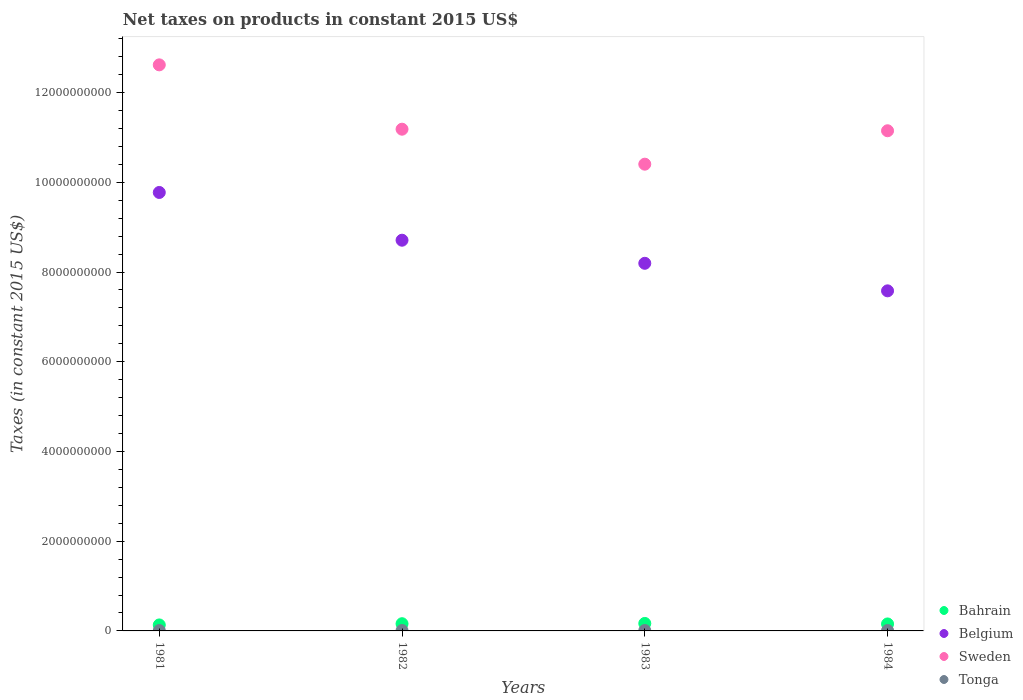How many different coloured dotlines are there?
Provide a succinct answer. 4. Is the number of dotlines equal to the number of legend labels?
Make the answer very short. Yes. What is the net taxes on products in Bahrain in 1984?
Ensure brevity in your answer.  1.56e+08. Across all years, what is the maximum net taxes on products in Belgium?
Your answer should be very brief. 9.77e+09. Across all years, what is the minimum net taxes on products in Tonga?
Keep it short and to the point. 8.35e+06. In which year was the net taxes on products in Sweden minimum?
Make the answer very short. 1983. What is the total net taxes on products in Belgium in the graph?
Give a very brief answer. 3.43e+1. What is the difference between the net taxes on products in Bahrain in 1982 and that in 1983?
Offer a very short reply. -6.12e+06. What is the difference between the net taxes on products in Tonga in 1983 and the net taxes on products in Sweden in 1981?
Keep it short and to the point. -1.26e+1. What is the average net taxes on products in Tonga per year?
Offer a very short reply. 8.68e+06. In the year 1983, what is the difference between the net taxes on products in Belgium and net taxes on products in Sweden?
Keep it short and to the point. -2.21e+09. In how many years, is the net taxes on products in Belgium greater than 5200000000 US$?
Make the answer very short. 4. What is the ratio of the net taxes on products in Belgium in 1982 to that in 1984?
Offer a terse response. 1.15. What is the difference between the highest and the second highest net taxes on products in Belgium?
Provide a short and direct response. 1.06e+09. What is the difference between the highest and the lowest net taxes on products in Tonga?
Keep it short and to the point. 5.08e+05. In how many years, is the net taxes on products in Tonga greater than the average net taxes on products in Tonga taken over all years?
Provide a short and direct response. 3. Is the sum of the net taxes on products in Belgium in 1982 and 1984 greater than the maximum net taxes on products in Sweden across all years?
Your answer should be compact. Yes. Is it the case that in every year, the sum of the net taxes on products in Bahrain and net taxes on products in Belgium  is greater than the sum of net taxes on products in Sweden and net taxes on products in Tonga?
Provide a succinct answer. No. Is it the case that in every year, the sum of the net taxes on products in Belgium and net taxes on products in Sweden  is greater than the net taxes on products in Bahrain?
Make the answer very short. Yes. Does the net taxes on products in Bahrain monotonically increase over the years?
Offer a very short reply. No. Is the net taxes on products in Tonga strictly greater than the net taxes on products in Sweden over the years?
Ensure brevity in your answer.  No. How many dotlines are there?
Keep it short and to the point. 4. What is the difference between two consecutive major ticks on the Y-axis?
Your response must be concise. 2.00e+09. Are the values on the major ticks of Y-axis written in scientific E-notation?
Ensure brevity in your answer.  No. How are the legend labels stacked?
Offer a very short reply. Vertical. What is the title of the graph?
Provide a short and direct response. Net taxes on products in constant 2015 US$. What is the label or title of the X-axis?
Provide a short and direct response. Years. What is the label or title of the Y-axis?
Give a very brief answer. Taxes (in constant 2015 US$). What is the Taxes (in constant 2015 US$) of Bahrain in 1981?
Offer a terse response. 1.34e+08. What is the Taxes (in constant 2015 US$) of Belgium in 1981?
Keep it short and to the point. 9.77e+09. What is the Taxes (in constant 2015 US$) of Sweden in 1981?
Provide a succinct answer. 1.26e+1. What is the Taxes (in constant 2015 US$) of Tonga in 1981?
Your answer should be compact. 8.35e+06. What is the Taxes (in constant 2015 US$) in Bahrain in 1982?
Offer a very short reply. 1.61e+08. What is the Taxes (in constant 2015 US$) in Belgium in 1982?
Ensure brevity in your answer.  8.71e+09. What is the Taxes (in constant 2015 US$) in Sweden in 1982?
Provide a succinct answer. 1.12e+1. What is the Taxes (in constant 2015 US$) of Tonga in 1982?
Provide a short and direct response. 8.80e+06. What is the Taxes (in constant 2015 US$) of Bahrain in 1983?
Your answer should be very brief. 1.67e+08. What is the Taxes (in constant 2015 US$) of Belgium in 1983?
Provide a short and direct response. 8.20e+09. What is the Taxes (in constant 2015 US$) of Sweden in 1983?
Make the answer very short. 1.04e+1. What is the Taxes (in constant 2015 US$) of Tonga in 1983?
Your answer should be compact. 8.72e+06. What is the Taxes (in constant 2015 US$) in Bahrain in 1984?
Give a very brief answer. 1.56e+08. What is the Taxes (in constant 2015 US$) in Belgium in 1984?
Make the answer very short. 7.58e+09. What is the Taxes (in constant 2015 US$) in Sweden in 1984?
Offer a terse response. 1.11e+1. What is the Taxes (in constant 2015 US$) in Tonga in 1984?
Make the answer very short. 8.86e+06. Across all years, what is the maximum Taxes (in constant 2015 US$) of Bahrain?
Your response must be concise. 1.67e+08. Across all years, what is the maximum Taxes (in constant 2015 US$) in Belgium?
Provide a succinct answer. 9.77e+09. Across all years, what is the maximum Taxes (in constant 2015 US$) in Sweden?
Offer a very short reply. 1.26e+1. Across all years, what is the maximum Taxes (in constant 2015 US$) in Tonga?
Provide a short and direct response. 8.86e+06. Across all years, what is the minimum Taxes (in constant 2015 US$) in Bahrain?
Make the answer very short. 1.34e+08. Across all years, what is the minimum Taxes (in constant 2015 US$) in Belgium?
Offer a terse response. 7.58e+09. Across all years, what is the minimum Taxes (in constant 2015 US$) in Sweden?
Provide a short and direct response. 1.04e+1. Across all years, what is the minimum Taxes (in constant 2015 US$) in Tonga?
Your answer should be compact. 8.35e+06. What is the total Taxes (in constant 2015 US$) of Bahrain in the graph?
Provide a succinct answer. 6.16e+08. What is the total Taxes (in constant 2015 US$) of Belgium in the graph?
Your answer should be very brief. 3.43e+1. What is the total Taxes (in constant 2015 US$) in Sweden in the graph?
Your answer should be very brief. 4.54e+1. What is the total Taxes (in constant 2015 US$) of Tonga in the graph?
Provide a succinct answer. 3.47e+07. What is the difference between the Taxes (in constant 2015 US$) in Bahrain in 1981 and that in 1982?
Offer a terse response. -2.71e+07. What is the difference between the Taxes (in constant 2015 US$) of Belgium in 1981 and that in 1982?
Offer a terse response. 1.06e+09. What is the difference between the Taxes (in constant 2015 US$) of Sweden in 1981 and that in 1982?
Provide a succinct answer. 1.43e+09. What is the difference between the Taxes (in constant 2015 US$) of Tonga in 1981 and that in 1982?
Your answer should be compact. -4.48e+05. What is the difference between the Taxes (in constant 2015 US$) of Bahrain in 1981 and that in 1983?
Your answer should be compact. -3.32e+07. What is the difference between the Taxes (in constant 2015 US$) in Belgium in 1981 and that in 1983?
Keep it short and to the point. 1.58e+09. What is the difference between the Taxes (in constant 2015 US$) in Sweden in 1981 and that in 1983?
Ensure brevity in your answer.  2.21e+09. What is the difference between the Taxes (in constant 2015 US$) of Tonga in 1981 and that in 1983?
Give a very brief answer. -3.70e+05. What is the difference between the Taxes (in constant 2015 US$) of Bahrain in 1981 and that in 1984?
Provide a short and direct response. -2.21e+07. What is the difference between the Taxes (in constant 2015 US$) of Belgium in 1981 and that in 1984?
Your response must be concise. 2.19e+09. What is the difference between the Taxes (in constant 2015 US$) in Sweden in 1981 and that in 1984?
Your answer should be compact. 1.47e+09. What is the difference between the Taxes (in constant 2015 US$) of Tonga in 1981 and that in 1984?
Make the answer very short. -5.08e+05. What is the difference between the Taxes (in constant 2015 US$) in Bahrain in 1982 and that in 1983?
Your answer should be very brief. -6.12e+06. What is the difference between the Taxes (in constant 2015 US$) of Belgium in 1982 and that in 1983?
Provide a succinct answer. 5.15e+08. What is the difference between the Taxes (in constant 2015 US$) of Sweden in 1982 and that in 1983?
Offer a very short reply. 7.80e+08. What is the difference between the Taxes (in constant 2015 US$) of Tonga in 1982 and that in 1983?
Give a very brief answer. 7.82e+04. What is the difference between the Taxes (in constant 2015 US$) of Bahrain in 1982 and that in 1984?
Keep it short and to the point. 5.05e+06. What is the difference between the Taxes (in constant 2015 US$) of Belgium in 1982 and that in 1984?
Your answer should be compact. 1.13e+09. What is the difference between the Taxes (in constant 2015 US$) in Sweden in 1982 and that in 1984?
Keep it short and to the point. 3.50e+07. What is the difference between the Taxes (in constant 2015 US$) in Tonga in 1982 and that in 1984?
Your answer should be very brief. -5.93e+04. What is the difference between the Taxes (in constant 2015 US$) in Bahrain in 1983 and that in 1984?
Ensure brevity in your answer.  1.12e+07. What is the difference between the Taxes (in constant 2015 US$) in Belgium in 1983 and that in 1984?
Keep it short and to the point. 6.14e+08. What is the difference between the Taxes (in constant 2015 US$) of Sweden in 1983 and that in 1984?
Offer a terse response. -7.45e+08. What is the difference between the Taxes (in constant 2015 US$) in Tonga in 1983 and that in 1984?
Offer a very short reply. -1.38e+05. What is the difference between the Taxes (in constant 2015 US$) of Bahrain in 1981 and the Taxes (in constant 2015 US$) of Belgium in 1982?
Ensure brevity in your answer.  -8.58e+09. What is the difference between the Taxes (in constant 2015 US$) in Bahrain in 1981 and the Taxes (in constant 2015 US$) in Sweden in 1982?
Your response must be concise. -1.11e+1. What is the difference between the Taxes (in constant 2015 US$) of Bahrain in 1981 and the Taxes (in constant 2015 US$) of Tonga in 1982?
Offer a very short reply. 1.25e+08. What is the difference between the Taxes (in constant 2015 US$) in Belgium in 1981 and the Taxes (in constant 2015 US$) in Sweden in 1982?
Keep it short and to the point. -1.41e+09. What is the difference between the Taxes (in constant 2015 US$) in Belgium in 1981 and the Taxes (in constant 2015 US$) in Tonga in 1982?
Provide a succinct answer. 9.77e+09. What is the difference between the Taxes (in constant 2015 US$) in Sweden in 1981 and the Taxes (in constant 2015 US$) in Tonga in 1982?
Provide a short and direct response. 1.26e+1. What is the difference between the Taxes (in constant 2015 US$) of Bahrain in 1981 and the Taxes (in constant 2015 US$) of Belgium in 1983?
Provide a short and direct response. -8.06e+09. What is the difference between the Taxes (in constant 2015 US$) in Bahrain in 1981 and the Taxes (in constant 2015 US$) in Sweden in 1983?
Your answer should be very brief. -1.03e+1. What is the difference between the Taxes (in constant 2015 US$) in Bahrain in 1981 and the Taxes (in constant 2015 US$) in Tonga in 1983?
Provide a short and direct response. 1.25e+08. What is the difference between the Taxes (in constant 2015 US$) in Belgium in 1981 and the Taxes (in constant 2015 US$) in Sweden in 1983?
Provide a short and direct response. -6.30e+08. What is the difference between the Taxes (in constant 2015 US$) of Belgium in 1981 and the Taxes (in constant 2015 US$) of Tonga in 1983?
Give a very brief answer. 9.77e+09. What is the difference between the Taxes (in constant 2015 US$) in Sweden in 1981 and the Taxes (in constant 2015 US$) in Tonga in 1983?
Your answer should be compact. 1.26e+1. What is the difference between the Taxes (in constant 2015 US$) in Bahrain in 1981 and the Taxes (in constant 2015 US$) in Belgium in 1984?
Ensure brevity in your answer.  -7.45e+09. What is the difference between the Taxes (in constant 2015 US$) in Bahrain in 1981 and the Taxes (in constant 2015 US$) in Sweden in 1984?
Give a very brief answer. -1.10e+1. What is the difference between the Taxes (in constant 2015 US$) of Bahrain in 1981 and the Taxes (in constant 2015 US$) of Tonga in 1984?
Provide a succinct answer. 1.25e+08. What is the difference between the Taxes (in constant 2015 US$) in Belgium in 1981 and the Taxes (in constant 2015 US$) in Sweden in 1984?
Ensure brevity in your answer.  -1.38e+09. What is the difference between the Taxes (in constant 2015 US$) in Belgium in 1981 and the Taxes (in constant 2015 US$) in Tonga in 1984?
Your answer should be compact. 9.77e+09. What is the difference between the Taxes (in constant 2015 US$) of Sweden in 1981 and the Taxes (in constant 2015 US$) of Tonga in 1984?
Ensure brevity in your answer.  1.26e+1. What is the difference between the Taxes (in constant 2015 US$) in Bahrain in 1982 and the Taxes (in constant 2015 US$) in Belgium in 1983?
Offer a very short reply. -8.03e+09. What is the difference between the Taxes (in constant 2015 US$) of Bahrain in 1982 and the Taxes (in constant 2015 US$) of Sweden in 1983?
Keep it short and to the point. -1.02e+1. What is the difference between the Taxes (in constant 2015 US$) of Bahrain in 1982 and the Taxes (in constant 2015 US$) of Tonga in 1983?
Offer a terse response. 1.52e+08. What is the difference between the Taxes (in constant 2015 US$) in Belgium in 1982 and the Taxes (in constant 2015 US$) in Sweden in 1983?
Provide a short and direct response. -1.69e+09. What is the difference between the Taxes (in constant 2015 US$) in Belgium in 1982 and the Taxes (in constant 2015 US$) in Tonga in 1983?
Your answer should be very brief. 8.70e+09. What is the difference between the Taxes (in constant 2015 US$) in Sweden in 1982 and the Taxes (in constant 2015 US$) in Tonga in 1983?
Offer a very short reply. 1.12e+1. What is the difference between the Taxes (in constant 2015 US$) in Bahrain in 1982 and the Taxes (in constant 2015 US$) in Belgium in 1984?
Give a very brief answer. -7.42e+09. What is the difference between the Taxes (in constant 2015 US$) of Bahrain in 1982 and the Taxes (in constant 2015 US$) of Sweden in 1984?
Give a very brief answer. -1.10e+1. What is the difference between the Taxes (in constant 2015 US$) in Bahrain in 1982 and the Taxes (in constant 2015 US$) in Tonga in 1984?
Ensure brevity in your answer.  1.52e+08. What is the difference between the Taxes (in constant 2015 US$) in Belgium in 1982 and the Taxes (in constant 2015 US$) in Sweden in 1984?
Keep it short and to the point. -2.44e+09. What is the difference between the Taxes (in constant 2015 US$) of Belgium in 1982 and the Taxes (in constant 2015 US$) of Tonga in 1984?
Your answer should be very brief. 8.70e+09. What is the difference between the Taxes (in constant 2015 US$) of Sweden in 1982 and the Taxes (in constant 2015 US$) of Tonga in 1984?
Offer a very short reply. 1.12e+1. What is the difference between the Taxes (in constant 2015 US$) of Bahrain in 1983 and the Taxes (in constant 2015 US$) of Belgium in 1984?
Offer a very short reply. -7.41e+09. What is the difference between the Taxes (in constant 2015 US$) of Bahrain in 1983 and the Taxes (in constant 2015 US$) of Sweden in 1984?
Provide a succinct answer. -1.10e+1. What is the difference between the Taxes (in constant 2015 US$) in Bahrain in 1983 and the Taxes (in constant 2015 US$) in Tonga in 1984?
Your response must be concise. 1.58e+08. What is the difference between the Taxes (in constant 2015 US$) of Belgium in 1983 and the Taxes (in constant 2015 US$) of Sweden in 1984?
Offer a terse response. -2.95e+09. What is the difference between the Taxes (in constant 2015 US$) in Belgium in 1983 and the Taxes (in constant 2015 US$) in Tonga in 1984?
Offer a terse response. 8.19e+09. What is the difference between the Taxes (in constant 2015 US$) of Sweden in 1983 and the Taxes (in constant 2015 US$) of Tonga in 1984?
Ensure brevity in your answer.  1.04e+1. What is the average Taxes (in constant 2015 US$) in Bahrain per year?
Ensure brevity in your answer.  1.54e+08. What is the average Taxes (in constant 2015 US$) in Belgium per year?
Offer a very short reply. 8.57e+09. What is the average Taxes (in constant 2015 US$) of Sweden per year?
Make the answer very short. 1.13e+1. What is the average Taxes (in constant 2015 US$) of Tonga per year?
Make the answer very short. 8.68e+06. In the year 1981, what is the difference between the Taxes (in constant 2015 US$) in Bahrain and Taxes (in constant 2015 US$) in Belgium?
Keep it short and to the point. -9.64e+09. In the year 1981, what is the difference between the Taxes (in constant 2015 US$) of Bahrain and Taxes (in constant 2015 US$) of Sweden?
Your response must be concise. -1.25e+1. In the year 1981, what is the difference between the Taxes (in constant 2015 US$) of Bahrain and Taxes (in constant 2015 US$) of Tonga?
Provide a succinct answer. 1.25e+08. In the year 1981, what is the difference between the Taxes (in constant 2015 US$) in Belgium and Taxes (in constant 2015 US$) in Sweden?
Offer a very short reply. -2.84e+09. In the year 1981, what is the difference between the Taxes (in constant 2015 US$) of Belgium and Taxes (in constant 2015 US$) of Tonga?
Give a very brief answer. 9.77e+09. In the year 1981, what is the difference between the Taxes (in constant 2015 US$) in Sweden and Taxes (in constant 2015 US$) in Tonga?
Offer a terse response. 1.26e+1. In the year 1982, what is the difference between the Taxes (in constant 2015 US$) of Bahrain and Taxes (in constant 2015 US$) of Belgium?
Your answer should be compact. -8.55e+09. In the year 1982, what is the difference between the Taxes (in constant 2015 US$) of Bahrain and Taxes (in constant 2015 US$) of Sweden?
Offer a terse response. -1.10e+1. In the year 1982, what is the difference between the Taxes (in constant 2015 US$) in Bahrain and Taxes (in constant 2015 US$) in Tonga?
Offer a very short reply. 1.52e+08. In the year 1982, what is the difference between the Taxes (in constant 2015 US$) in Belgium and Taxes (in constant 2015 US$) in Sweden?
Your response must be concise. -2.47e+09. In the year 1982, what is the difference between the Taxes (in constant 2015 US$) in Belgium and Taxes (in constant 2015 US$) in Tonga?
Keep it short and to the point. 8.70e+09. In the year 1982, what is the difference between the Taxes (in constant 2015 US$) in Sweden and Taxes (in constant 2015 US$) in Tonga?
Your answer should be very brief. 1.12e+1. In the year 1983, what is the difference between the Taxes (in constant 2015 US$) of Bahrain and Taxes (in constant 2015 US$) of Belgium?
Ensure brevity in your answer.  -8.03e+09. In the year 1983, what is the difference between the Taxes (in constant 2015 US$) of Bahrain and Taxes (in constant 2015 US$) of Sweden?
Make the answer very short. -1.02e+1. In the year 1983, what is the difference between the Taxes (in constant 2015 US$) in Bahrain and Taxes (in constant 2015 US$) in Tonga?
Provide a short and direct response. 1.58e+08. In the year 1983, what is the difference between the Taxes (in constant 2015 US$) of Belgium and Taxes (in constant 2015 US$) of Sweden?
Offer a terse response. -2.21e+09. In the year 1983, what is the difference between the Taxes (in constant 2015 US$) in Belgium and Taxes (in constant 2015 US$) in Tonga?
Make the answer very short. 8.19e+09. In the year 1983, what is the difference between the Taxes (in constant 2015 US$) of Sweden and Taxes (in constant 2015 US$) of Tonga?
Provide a short and direct response. 1.04e+1. In the year 1984, what is the difference between the Taxes (in constant 2015 US$) of Bahrain and Taxes (in constant 2015 US$) of Belgium?
Offer a terse response. -7.43e+09. In the year 1984, what is the difference between the Taxes (in constant 2015 US$) in Bahrain and Taxes (in constant 2015 US$) in Sweden?
Give a very brief answer. -1.10e+1. In the year 1984, what is the difference between the Taxes (in constant 2015 US$) of Bahrain and Taxes (in constant 2015 US$) of Tonga?
Make the answer very short. 1.47e+08. In the year 1984, what is the difference between the Taxes (in constant 2015 US$) of Belgium and Taxes (in constant 2015 US$) of Sweden?
Make the answer very short. -3.57e+09. In the year 1984, what is the difference between the Taxes (in constant 2015 US$) in Belgium and Taxes (in constant 2015 US$) in Tonga?
Offer a very short reply. 7.57e+09. In the year 1984, what is the difference between the Taxes (in constant 2015 US$) of Sweden and Taxes (in constant 2015 US$) of Tonga?
Give a very brief answer. 1.11e+1. What is the ratio of the Taxes (in constant 2015 US$) in Bahrain in 1981 to that in 1982?
Offer a very short reply. 0.83. What is the ratio of the Taxes (in constant 2015 US$) of Belgium in 1981 to that in 1982?
Provide a short and direct response. 1.12. What is the ratio of the Taxes (in constant 2015 US$) of Sweden in 1981 to that in 1982?
Provide a succinct answer. 1.13. What is the ratio of the Taxes (in constant 2015 US$) in Tonga in 1981 to that in 1982?
Ensure brevity in your answer.  0.95. What is the ratio of the Taxes (in constant 2015 US$) in Bahrain in 1981 to that in 1983?
Keep it short and to the point. 0.8. What is the ratio of the Taxes (in constant 2015 US$) of Belgium in 1981 to that in 1983?
Make the answer very short. 1.19. What is the ratio of the Taxes (in constant 2015 US$) of Sweden in 1981 to that in 1983?
Your answer should be very brief. 1.21. What is the ratio of the Taxes (in constant 2015 US$) of Tonga in 1981 to that in 1983?
Keep it short and to the point. 0.96. What is the ratio of the Taxes (in constant 2015 US$) in Bahrain in 1981 to that in 1984?
Offer a very short reply. 0.86. What is the ratio of the Taxes (in constant 2015 US$) in Belgium in 1981 to that in 1984?
Make the answer very short. 1.29. What is the ratio of the Taxes (in constant 2015 US$) of Sweden in 1981 to that in 1984?
Give a very brief answer. 1.13. What is the ratio of the Taxes (in constant 2015 US$) of Tonga in 1981 to that in 1984?
Give a very brief answer. 0.94. What is the ratio of the Taxes (in constant 2015 US$) of Bahrain in 1982 to that in 1983?
Provide a short and direct response. 0.96. What is the ratio of the Taxes (in constant 2015 US$) of Belgium in 1982 to that in 1983?
Offer a terse response. 1.06. What is the ratio of the Taxes (in constant 2015 US$) in Sweden in 1982 to that in 1983?
Ensure brevity in your answer.  1.07. What is the ratio of the Taxes (in constant 2015 US$) of Bahrain in 1982 to that in 1984?
Offer a very short reply. 1.03. What is the ratio of the Taxes (in constant 2015 US$) of Belgium in 1982 to that in 1984?
Ensure brevity in your answer.  1.15. What is the ratio of the Taxes (in constant 2015 US$) of Bahrain in 1983 to that in 1984?
Offer a very short reply. 1.07. What is the ratio of the Taxes (in constant 2015 US$) of Belgium in 1983 to that in 1984?
Offer a terse response. 1.08. What is the ratio of the Taxes (in constant 2015 US$) in Sweden in 1983 to that in 1984?
Give a very brief answer. 0.93. What is the ratio of the Taxes (in constant 2015 US$) of Tonga in 1983 to that in 1984?
Offer a terse response. 0.98. What is the difference between the highest and the second highest Taxes (in constant 2015 US$) in Bahrain?
Give a very brief answer. 6.12e+06. What is the difference between the highest and the second highest Taxes (in constant 2015 US$) of Belgium?
Provide a succinct answer. 1.06e+09. What is the difference between the highest and the second highest Taxes (in constant 2015 US$) in Sweden?
Keep it short and to the point. 1.43e+09. What is the difference between the highest and the second highest Taxes (in constant 2015 US$) of Tonga?
Your answer should be compact. 5.93e+04. What is the difference between the highest and the lowest Taxes (in constant 2015 US$) in Bahrain?
Provide a short and direct response. 3.32e+07. What is the difference between the highest and the lowest Taxes (in constant 2015 US$) in Belgium?
Offer a very short reply. 2.19e+09. What is the difference between the highest and the lowest Taxes (in constant 2015 US$) in Sweden?
Your response must be concise. 2.21e+09. What is the difference between the highest and the lowest Taxes (in constant 2015 US$) of Tonga?
Give a very brief answer. 5.08e+05. 